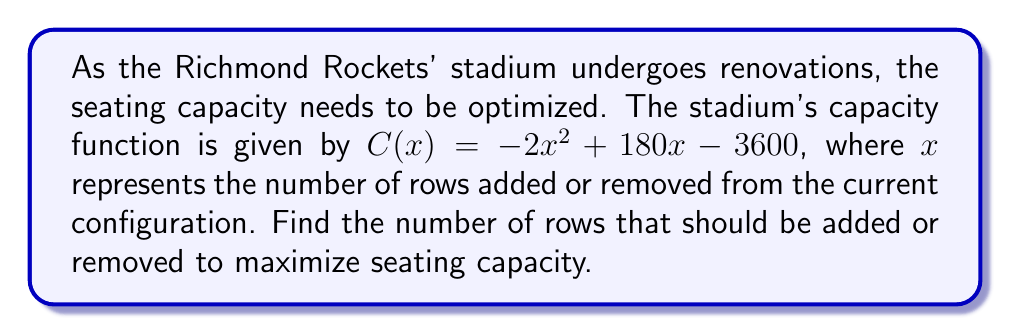Solve this math problem. To find the optimal number of rows, we need to find the vertex of the quadratic function $C(x) = -2x^2 + 180x - 3600$. The vertex represents the maximum point of the parabola.

Step 1: Identify the coefficients
$a = -2$, $b = 180$, $c = -3600$

Step 2: Use the vertex formula $x = -\frac{b}{2a}$
$$x = -\frac{180}{2(-2)} = -\frac{180}{-4} = 45$$

Step 3: Interpret the result
The positive value of 45 indicates that 45 rows should be added to the current configuration to maximize seating capacity.

Step 4: Verify by factoring (optional)
We can factor the polynomial to confirm:
$$C(x) = -2(x^2 - 90x + 1800)$$
$$C(x) = -2(x - 45)^2 + 4050$$

This factored form confirms that the vertex occurs at $x = 45$.
Answer: 45 rows 